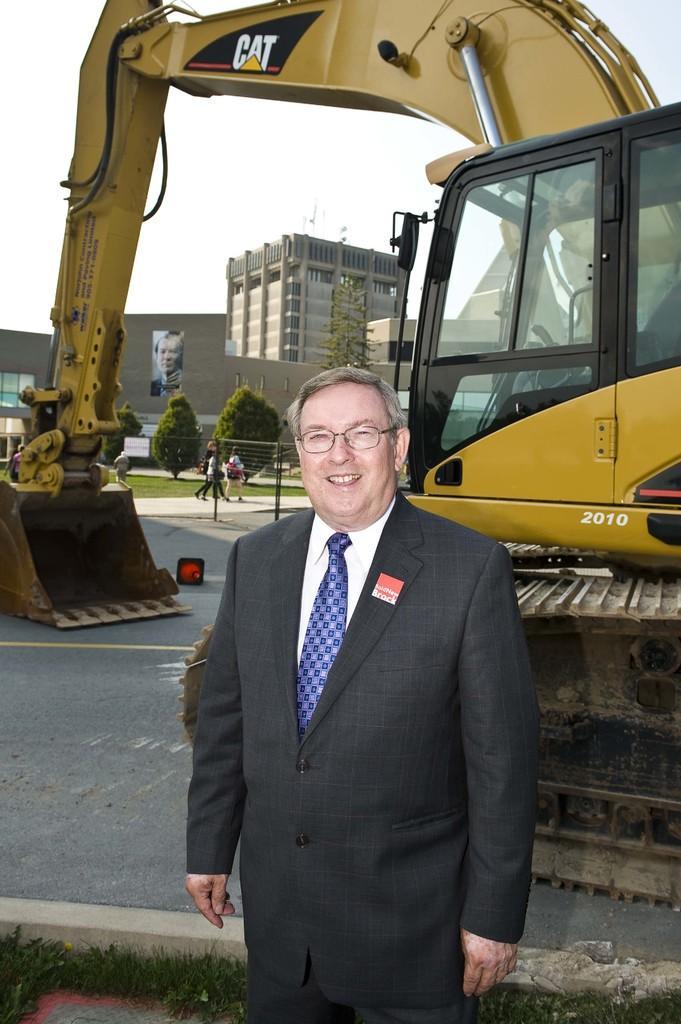How would you summarize this image in a sentence or two? There is one man standing and wearing a blazer at the bottom of this image. We can see a crane machine on the right side of this image. There are trees and buildings present in the middle of this image and the sky is in the background. 